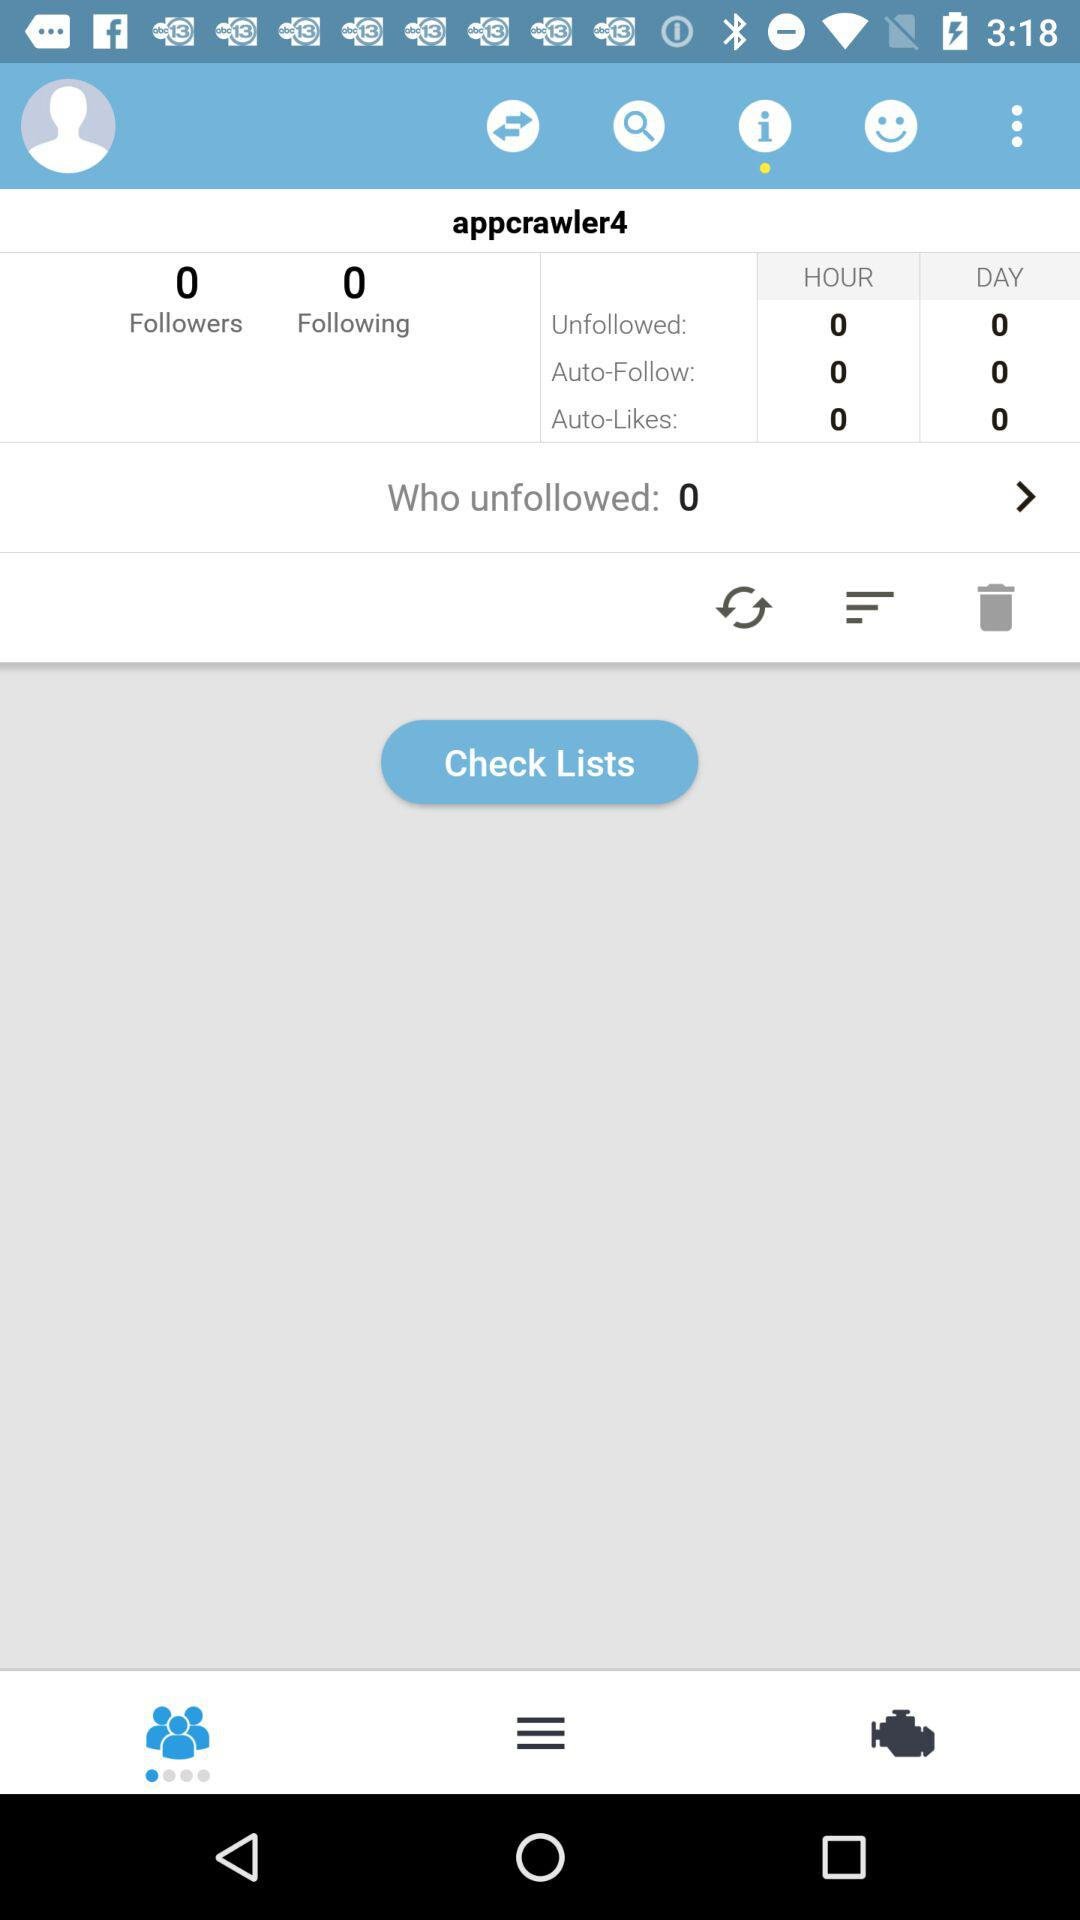What's the username? The username is "appcrawler4". 